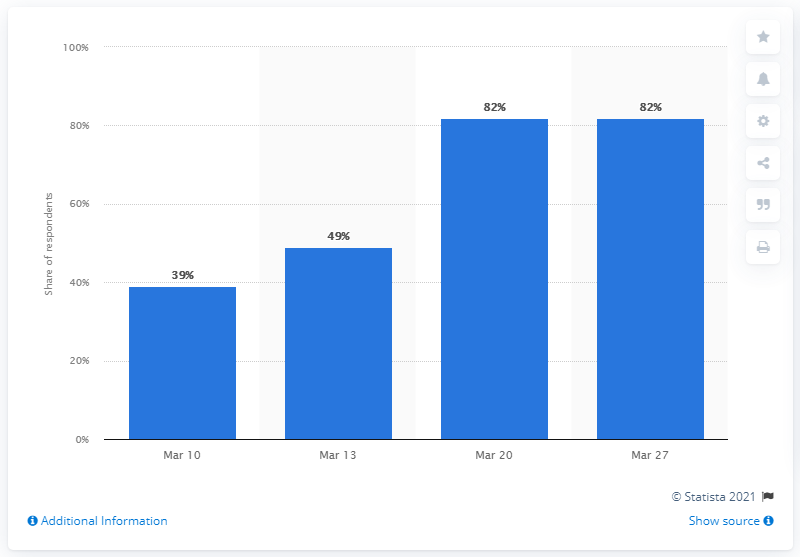Identify some key points in this picture. According to a survey conducted in France, by March 27, approximately 82% of the population had avoided crowded public places due to the pandemic. 